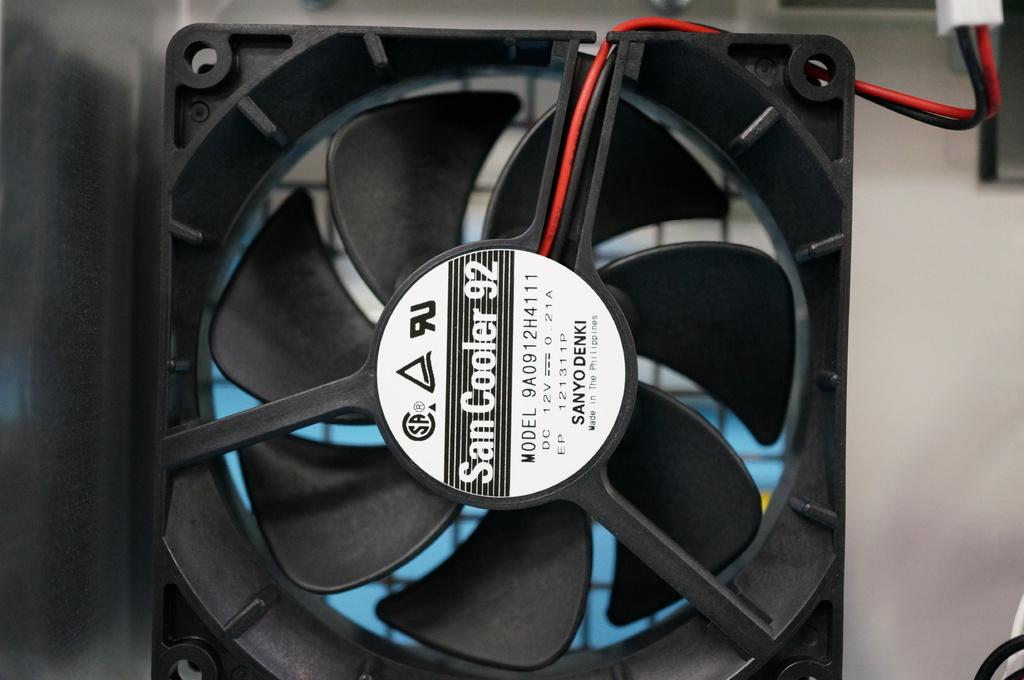What is the main subject in the center of the image? There is a black object in the center of the image. What can be seen on the black object? There is text written on the black object. What type of wires are present in the image? There are red and black wires in the image. Can you describe the zephyr blowing through the yard in the image? There is no mention of a zephyr or a yard in the image; it only features a black object with text and red and black wires. 